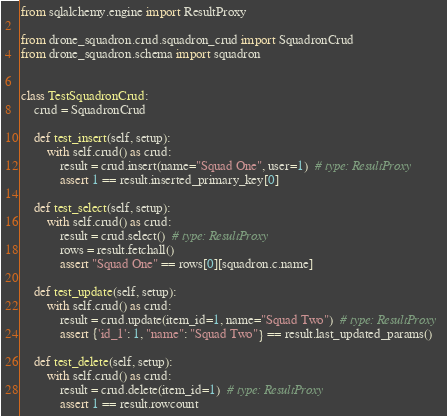Convert code to text. <code><loc_0><loc_0><loc_500><loc_500><_Python_>from sqlalchemy.engine import ResultProxy

from drone_squadron.crud.squadron_crud import SquadronCrud
from drone_squadron.schema import squadron


class TestSquadronCrud:
    crud = SquadronCrud

    def test_insert(self, setup):
        with self.crud() as crud:
            result = crud.insert(name="Squad One", user=1)  # type: ResultProxy
            assert 1 == result.inserted_primary_key[0]

    def test_select(self, setup):
        with self.crud() as crud:
            result = crud.select()  # type: ResultProxy
            rows = result.fetchall()
            assert "Squad One" == rows[0][squadron.c.name]

    def test_update(self, setup):
        with self.crud() as crud:
            result = crud.update(item_id=1, name="Squad Two")  # type: ResultProxy
            assert {'id_1': 1, "name": "Squad Two"} == result.last_updated_params()

    def test_delete(self, setup):
        with self.crud() as crud:
            result = crud.delete(item_id=1)  # type: ResultProxy
            assert 1 == result.rowcount
</code> 